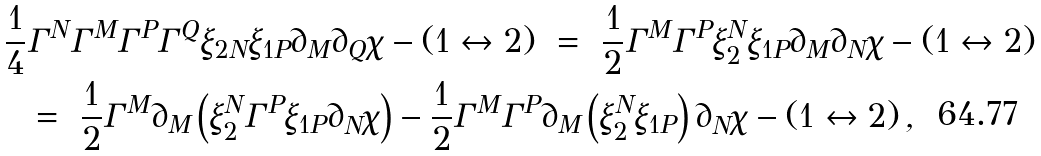<formula> <loc_0><loc_0><loc_500><loc_500>\frac { 1 } { 4 } & \Gamma ^ { N } \Gamma ^ { M } \Gamma ^ { P } \Gamma ^ { Q } \xi _ { 2 N } \xi _ { 1 P } \partial _ { M } \partial _ { Q } \chi - ( 1 \leftrightarrow 2 ) \ = \ \frac { 1 } { 2 } \Gamma ^ { M } \Gamma ^ { P } \xi _ { 2 } ^ { N } \xi _ { 1 P } \partial _ { M } \partial _ { N } \chi - ( 1 \leftrightarrow 2 ) \\ \ & = \ \frac { 1 } { 2 } \Gamma ^ { M } \partial _ { M } \left ( \xi _ { 2 } ^ { N } \Gamma ^ { P } \xi _ { 1 P } \partial _ { N } \chi \right ) - \frac { 1 } { 2 } \Gamma ^ { M } \Gamma ^ { P } \partial _ { M } \left ( \xi _ { 2 } ^ { N } \xi _ { 1 P } \right ) \partial _ { N } \chi - ( 1 \leftrightarrow 2 ) \, ,</formula> 